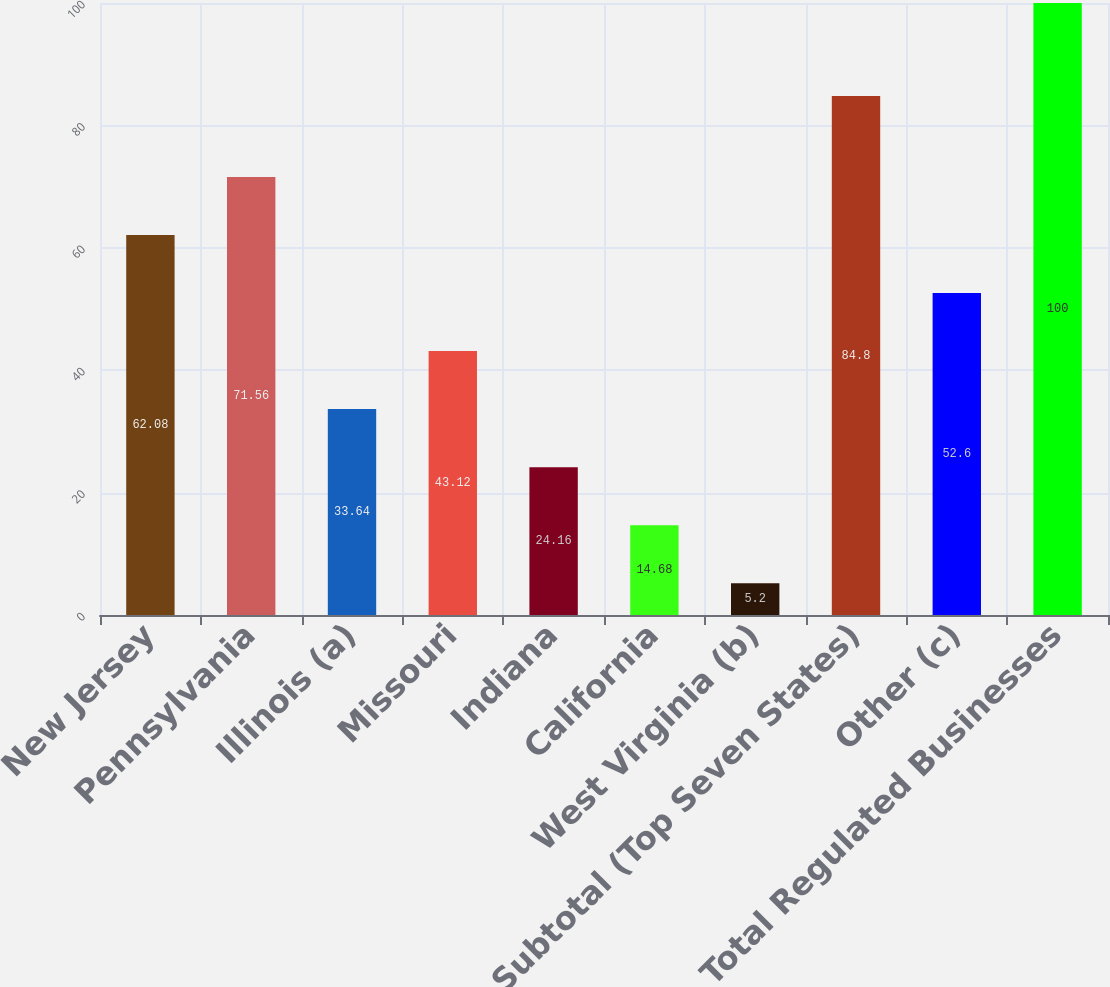Convert chart to OTSL. <chart><loc_0><loc_0><loc_500><loc_500><bar_chart><fcel>New Jersey<fcel>Pennsylvania<fcel>Illinois (a)<fcel>Missouri<fcel>Indiana<fcel>California<fcel>West Virginia (b)<fcel>Subtotal (Top Seven States)<fcel>Other (c)<fcel>Total Regulated Businesses<nl><fcel>62.08<fcel>71.56<fcel>33.64<fcel>43.12<fcel>24.16<fcel>14.68<fcel>5.2<fcel>84.8<fcel>52.6<fcel>100<nl></chart> 